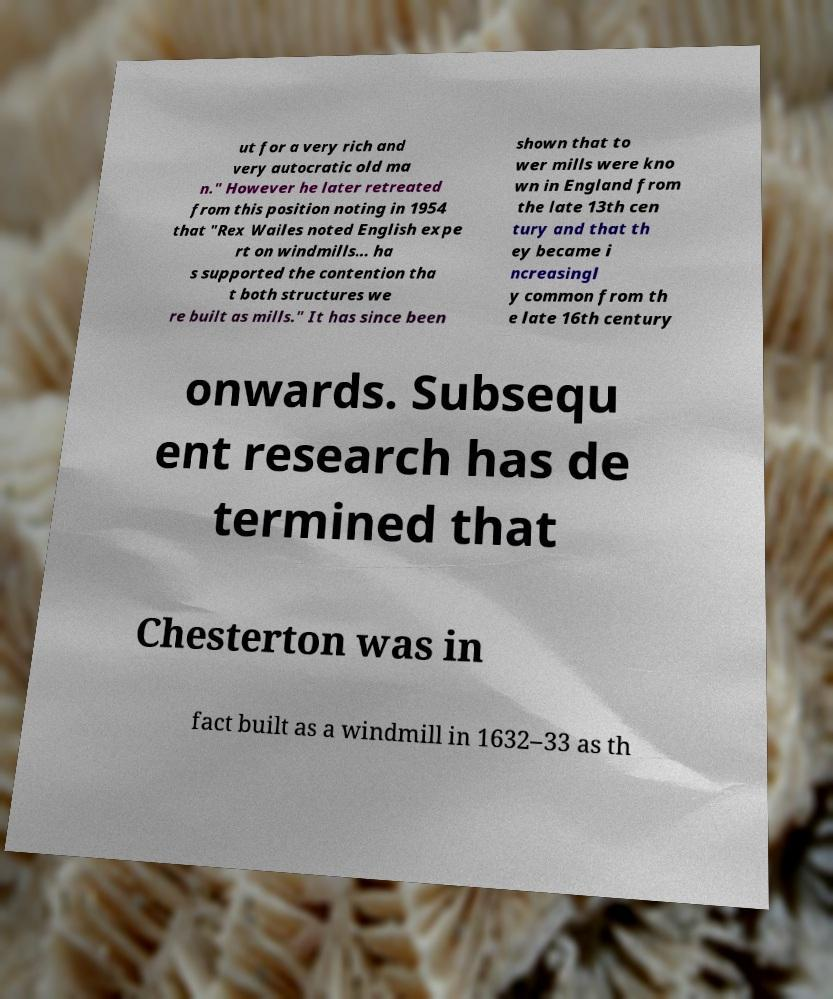Can you accurately transcribe the text from the provided image for me? ut for a very rich and very autocratic old ma n." However he later retreated from this position noting in 1954 that "Rex Wailes noted English expe rt on windmills... ha s supported the contention tha t both structures we re built as mills." It has since been shown that to wer mills were kno wn in England from the late 13th cen tury and that th ey became i ncreasingl y common from th e late 16th century onwards. Subsequ ent research has de termined that Chesterton was in fact built as a windmill in 1632–33 as th 